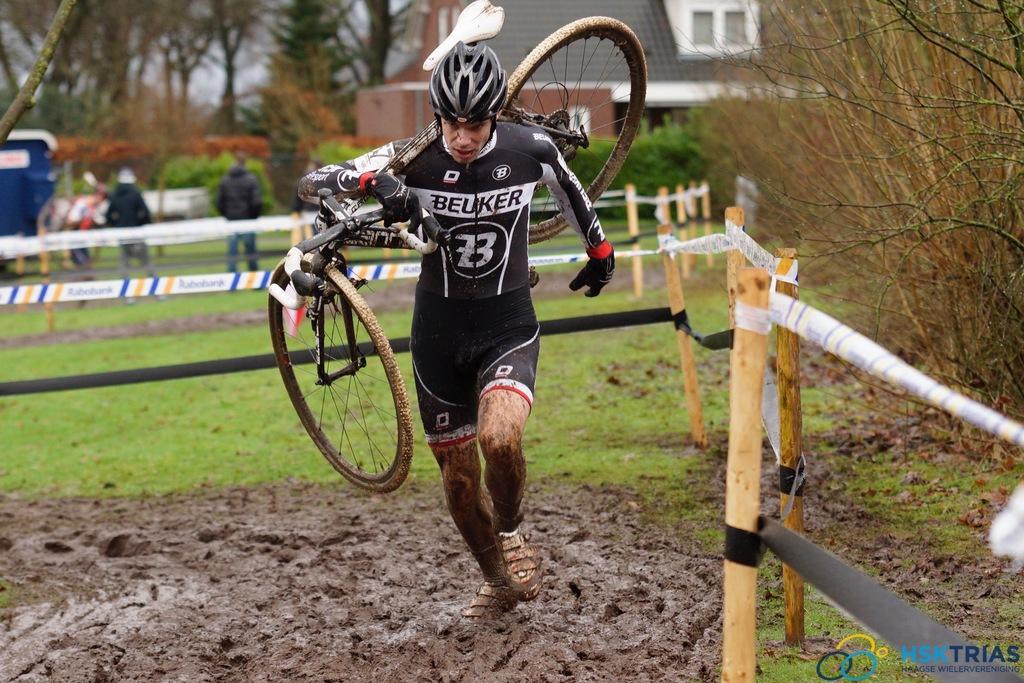Is the man racing?
Keep it short and to the point. Yes. Who is this man's sponsor?
Make the answer very short. Beuker. 